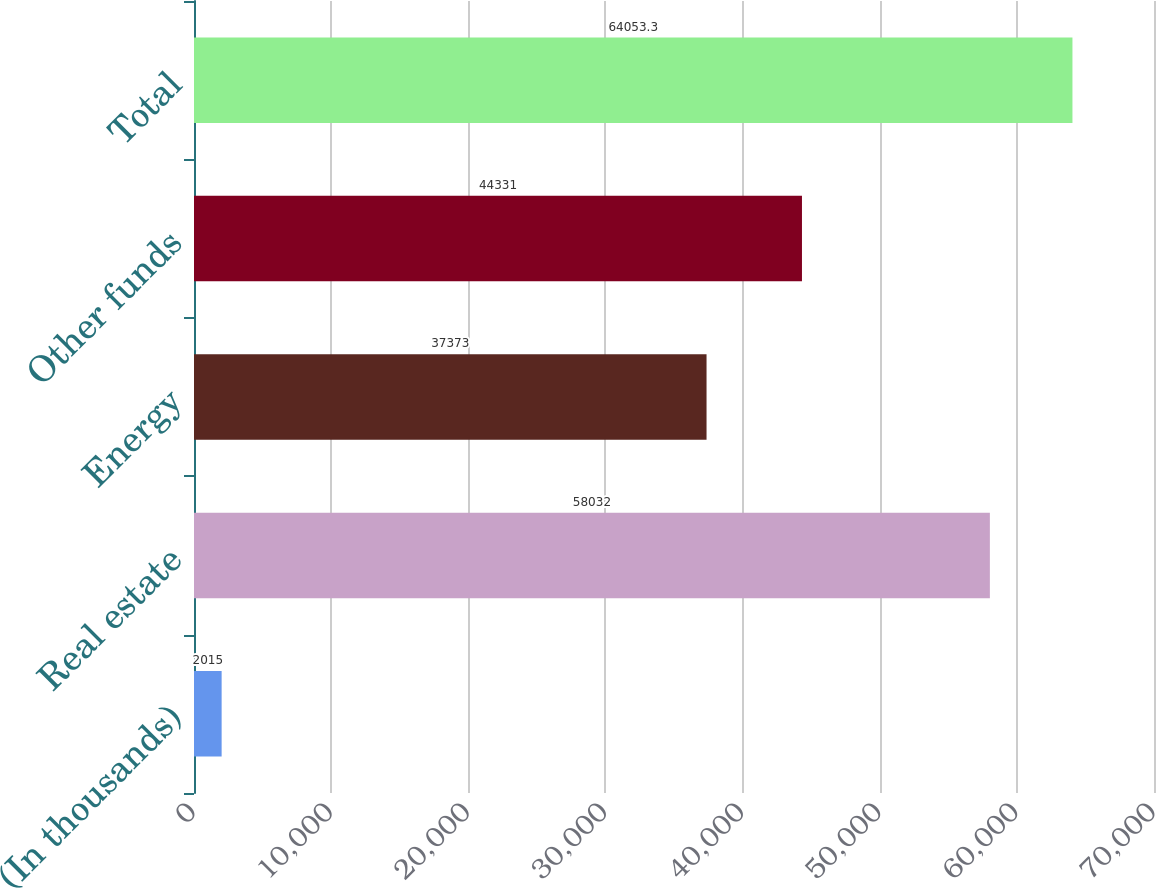Convert chart to OTSL. <chart><loc_0><loc_0><loc_500><loc_500><bar_chart><fcel>(In thousands)<fcel>Real estate<fcel>Energy<fcel>Other funds<fcel>Total<nl><fcel>2015<fcel>58032<fcel>37373<fcel>44331<fcel>64053.3<nl></chart> 